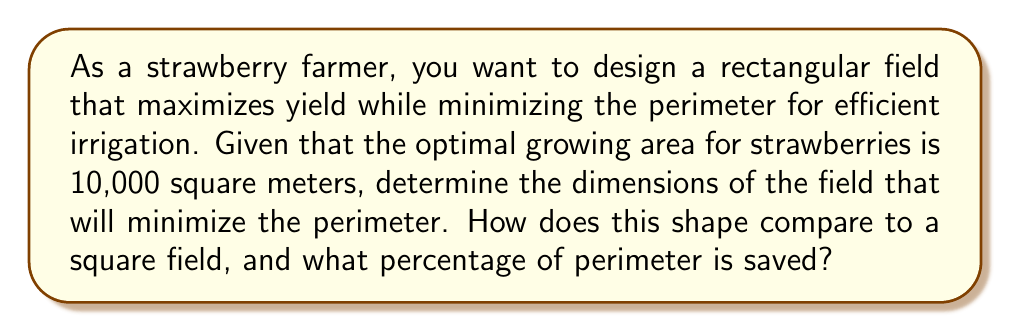Help me with this question. Let's approach this step-by-step:

1) Let the length of the field be $l$ and the width be $w$. We know the area is fixed at 10,000 square meters:

   $$A = lw = 10,000$$

2) The perimeter $P$ of the field is given by:

   $$P = 2l + 2w$$

3) We want to minimize $P$ subject to the constraint $lw = 10,000$. We can express $w$ in terms of $l$:

   $$w = \frac{10,000}{l}$$

4) Substituting this into the perimeter equation:

   $$P = 2l + 2(\frac{10,000}{l}) = 2l + \frac{20,000}{l}$$

5) To find the minimum, we differentiate $P$ with respect to $l$ and set it to zero:

   $$\frac{dP}{dl} = 2 - \frac{20,000}{l^2} = 0$$

6) Solving this equation:

   $$2 = \frac{20,000}{l^2}$$
   $$l^2 = 10,000$$
   $$l = 100$$

7) Since $lw = 10,000$, $w$ must also equal 100.

8) Therefore, the optimal shape is a square with sides of 100 meters.

9) The perimeter of this optimal field is:

   $$P_{optimal} = 2(100) + 2(100) = 400\text{ meters}$$

10) To compare with a non-square rectangular field, let's consider a field that's twice as long as it is wide:

    $$l = 2w$$
    $$2w \cdot w = 10,000$$
    $$w = \sqrt{5,000} \approx 70.71\text{ meters}$$
    $$l \approx 141.42\text{ meters}$$

    The perimeter of this field would be:

    $$P_{rectangle} = 2(141.42) + 2(70.71) \approx 424.26\text{ meters}$$

11) The percentage of perimeter saved by using the optimal square shape is:

    $$\text{Savings} = \frac{424.26 - 400}{424.26} \times 100\% \approx 5.72\%$$

[asy]
size(200);
draw((0,0)--(100,0)--(100,100)--(0,100)--cycle);
label("100 m", (50,0), S);
label("100 m", (0,50), W);
label("Optimal Square Field", (50,110), N);
[/asy]
Answer: The optimal dimensions for the strawberry field are 100 meters by 100 meters (a square). This shape saves approximately 5.72% of the perimeter compared to a rectangular field that is twice as long as it is wide. 